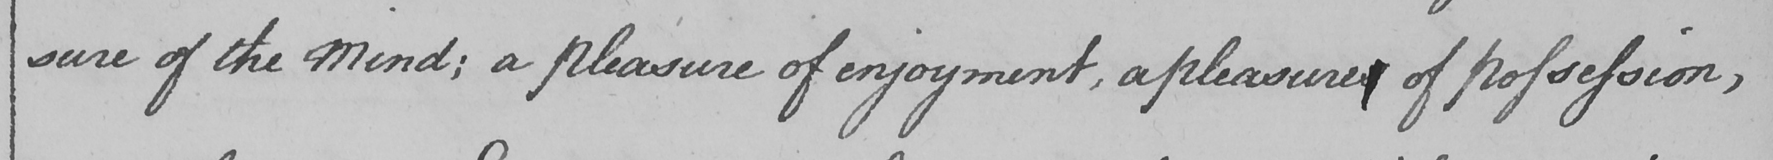What is written in this line of handwriting? sure of the Mind ; a pleasure of enjoyment , a pleasure of possession , 